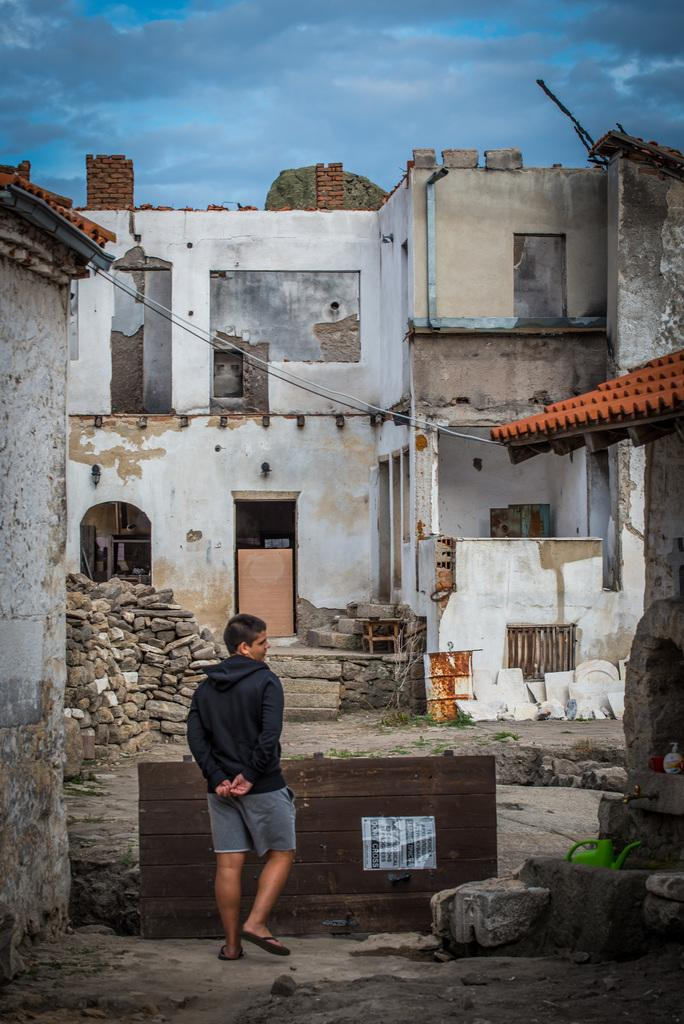What type of structures can be seen in the image? There are buildings in the image. What is the person in the image doing? There is a person walking on the ground in the image. What material is the wooden object made of? The wooden object in the image is made of wood. What separates the buildings from the sky in the image? There is a wall in the image. What is visible at the top of the image? The sky is visible at the top of the image. What type of twig is the person holding in the image? There is no twig present in the image; the person is walking on the ground without holding any object. 